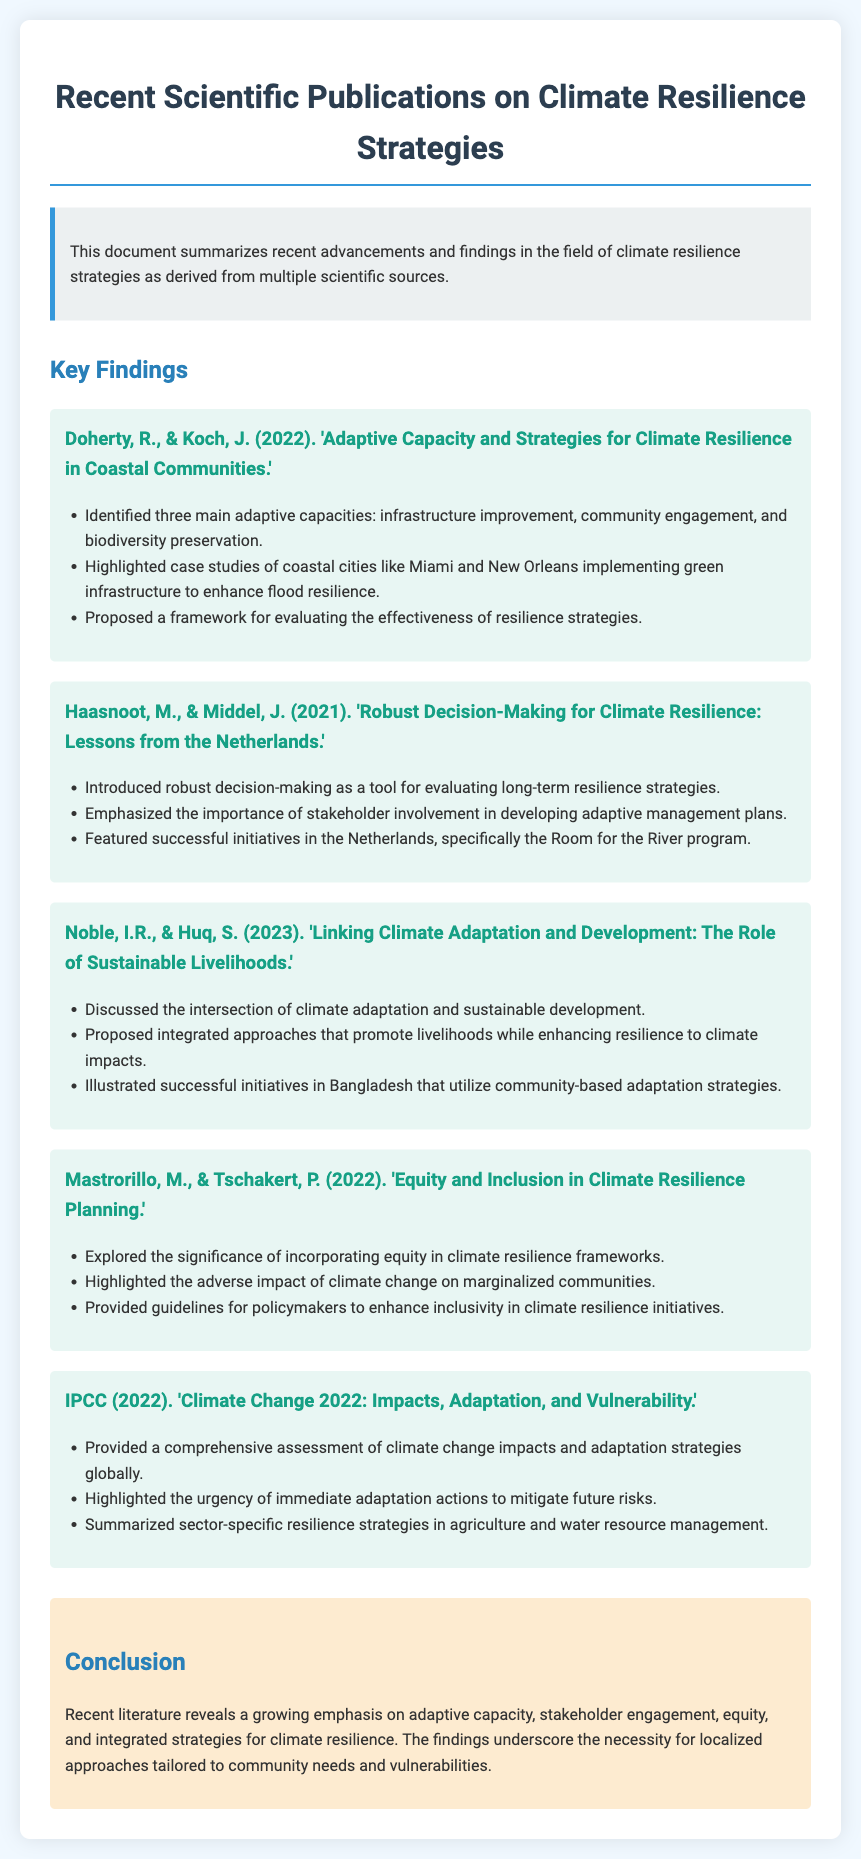What is the title of the document? The title of the document is provided at the top of the rendered webpage.
Answer: Recent Scientific Publications on Climate Resilience Strategies Who authored the publication focusing on coastal communities' adaptive capacity? The authors are mentioned in the publication section discussing adaptive capacity and its strategies.
Answer: Doherty, R., & Koch, J In what year was the publication by Haasnoot and Middel released? The year of publication is indicated in parentheses next to the authors' names.
Answer: 2021 What framework is proposed by Doherty and Koch to evaluate resilience strategies? The framework is specifically named in the findings of their publication.
Answer: Framework for evaluating the effectiveness of resilience strategies What two aspects are discussed in Noble and Huq's publication? The publication specifies two main themes within the title and the ul points.
Answer: Climate adaptation and sustainable development Highlight a key initiative featured in the publication by Haasnoot and Middel. The initiative is mentioned directly in the findings of their publication.
Answer: Room for the River program What is emphasized as significant in Mastrorillo and Tschakert's work? The emphasis is outlined in the findings section of their publication.
Answer: Incorporating equity in climate resilience frameworks Which organization published a comprehensive assessment on climate change impacts in 2022? The organization is mentioned in the title of the publication and its details.
Answer: IPCC What is the primary theme addressed in the conclusion of the document? The primary theme is summarized in the conclusion's text.
Answer: Adaptive capacity, stakeholder engagement, equity, and integrated strategies 